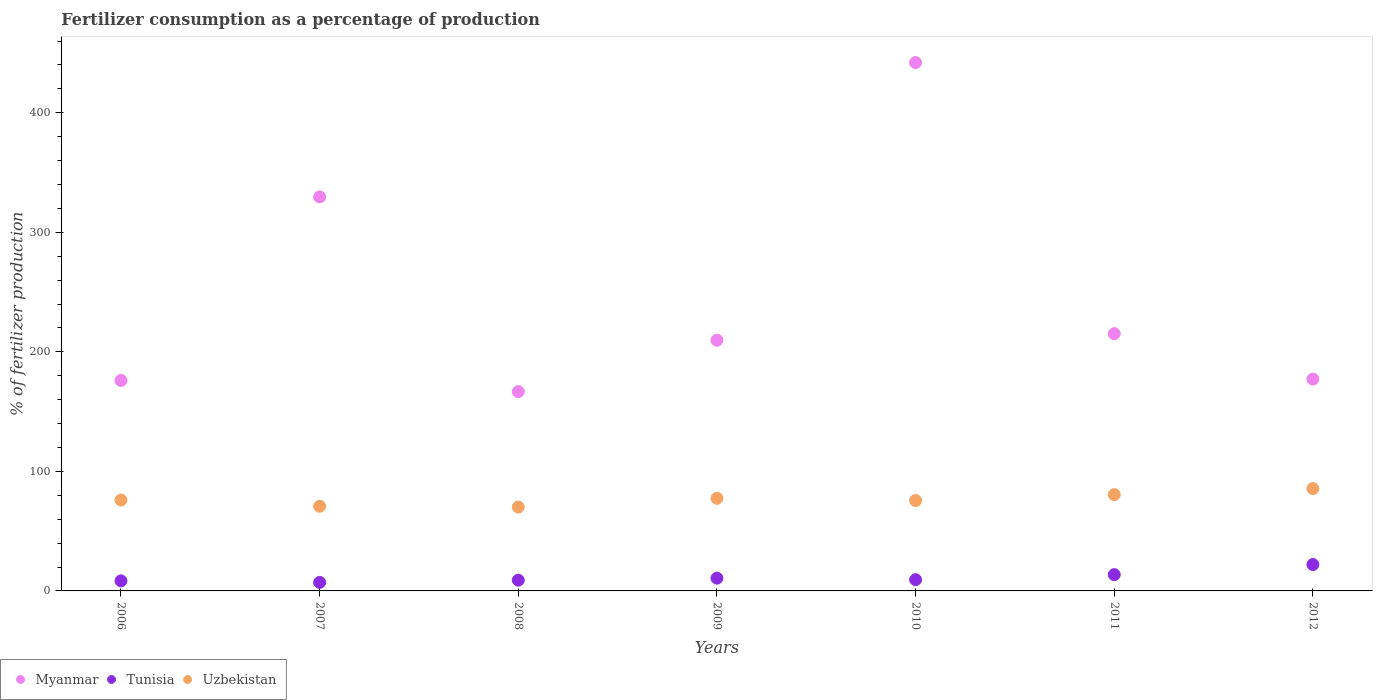What is the percentage of fertilizers consumed in Myanmar in 2007?
Keep it short and to the point. 329.61. Across all years, what is the maximum percentage of fertilizers consumed in Tunisia?
Provide a succinct answer. 22.07. Across all years, what is the minimum percentage of fertilizers consumed in Tunisia?
Keep it short and to the point. 7.13. In which year was the percentage of fertilizers consumed in Uzbekistan minimum?
Make the answer very short. 2008. What is the total percentage of fertilizers consumed in Myanmar in the graph?
Provide a succinct answer. 1716.48. What is the difference between the percentage of fertilizers consumed in Myanmar in 2006 and that in 2011?
Provide a short and direct response. -39.09. What is the difference between the percentage of fertilizers consumed in Myanmar in 2011 and the percentage of fertilizers consumed in Tunisia in 2010?
Your answer should be very brief. 205.79. What is the average percentage of fertilizers consumed in Uzbekistan per year?
Give a very brief answer. 76.61. In the year 2008, what is the difference between the percentage of fertilizers consumed in Myanmar and percentage of fertilizers consumed in Uzbekistan?
Provide a succinct answer. 96.5. In how many years, is the percentage of fertilizers consumed in Tunisia greater than 440 %?
Offer a terse response. 0. What is the ratio of the percentage of fertilizers consumed in Uzbekistan in 2006 to that in 2012?
Make the answer very short. 0.89. Is the percentage of fertilizers consumed in Tunisia in 2006 less than that in 2009?
Make the answer very short. Yes. Is the difference between the percentage of fertilizers consumed in Myanmar in 2007 and 2012 greater than the difference between the percentage of fertilizers consumed in Uzbekistan in 2007 and 2012?
Make the answer very short. Yes. What is the difference between the highest and the second highest percentage of fertilizers consumed in Uzbekistan?
Provide a short and direct response. 5.05. What is the difference between the highest and the lowest percentage of fertilizers consumed in Myanmar?
Offer a terse response. 275.3. Is the sum of the percentage of fertilizers consumed in Myanmar in 2009 and 2012 greater than the maximum percentage of fertilizers consumed in Tunisia across all years?
Your answer should be very brief. Yes. Is the percentage of fertilizers consumed in Tunisia strictly less than the percentage of fertilizers consumed in Myanmar over the years?
Your answer should be compact. Yes. How many years are there in the graph?
Your answer should be compact. 7. Are the values on the major ticks of Y-axis written in scientific E-notation?
Make the answer very short. No. Where does the legend appear in the graph?
Your response must be concise. Bottom left. How are the legend labels stacked?
Provide a succinct answer. Horizontal. What is the title of the graph?
Make the answer very short. Fertilizer consumption as a percentage of production. Does "Chad" appear as one of the legend labels in the graph?
Ensure brevity in your answer.  No. What is the label or title of the Y-axis?
Keep it short and to the point. % of fertilizer production. What is the % of fertilizer production in Myanmar in 2006?
Ensure brevity in your answer.  176.08. What is the % of fertilizer production in Tunisia in 2006?
Your answer should be compact. 8.41. What is the % of fertilizer production in Uzbekistan in 2006?
Ensure brevity in your answer.  76.02. What is the % of fertilizer production of Myanmar in 2007?
Make the answer very short. 329.61. What is the % of fertilizer production in Tunisia in 2007?
Give a very brief answer. 7.13. What is the % of fertilizer production in Uzbekistan in 2007?
Your answer should be very brief. 70.8. What is the % of fertilizer production of Myanmar in 2008?
Your answer should be very brief. 166.68. What is the % of fertilizer production of Tunisia in 2008?
Your answer should be very brief. 8.99. What is the % of fertilizer production of Uzbekistan in 2008?
Your answer should be compact. 70.18. What is the % of fertilizer production in Myanmar in 2009?
Ensure brevity in your answer.  209.73. What is the % of fertilizer production of Tunisia in 2009?
Ensure brevity in your answer.  10.66. What is the % of fertilizer production of Uzbekistan in 2009?
Make the answer very short. 77.46. What is the % of fertilizer production in Myanmar in 2010?
Provide a short and direct response. 441.98. What is the % of fertilizer production in Tunisia in 2010?
Your answer should be very brief. 9.38. What is the % of fertilizer production of Uzbekistan in 2010?
Give a very brief answer. 75.64. What is the % of fertilizer production in Myanmar in 2011?
Your answer should be compact. 215.18. What is the % of fertilizer production of Tunisia in 2011?
Offer a terse response. 13.63. What is the % of fertilizer production in Uzbekistan in 2011?
Your answer should be very brief. 80.55. What is the % of fertilizer production of Myanmar in 2012?
Offer a very short reply. 177.22. What is the % of fertilizer production of Tunisia in 2012?
Provide a short and direct response. 22.07. What is the % of fertilizer production in Uzbekistan in 2012?
Offer a very short reply. 85.6. Across all years, what is the maximum % of fertilizer production in Myanmar?
Make the answer very short. 441.98. Across all years, what is the maximum % of fertilizer production of Tunisia?
Ensure brevity in your answer.  22.07. Across all years, what is the maximum % of fertilizer production in Uzbekistan?
Keep it short and to the point. 85.6. Across all years, what is the minimum % of fertilizer production of Myanmar?
Your answer should be very brief. 166.68. Across all years, what is the minimum % of fertilizer production of Tunisia?
Your answer should be compact. 7.13. Across all years, what is the minimum % of fertilizer production in Uzbekistan?
Your answer should be compact. 70.18. What is the total % of fertilizer production in Myanmar in the graph?
Ensure brevity in your answer.  1716.48. What is the total % of fertilizer production of Tunisia in the graph?
Make the answer very short. 80.27. What is the total % of fertilizer production of Uzbekistan in the graph?
Ensure brevity in your answer.  536.26. What is the difference between the % of fertilizer production of Myanmar in 2006 and that in 2007?
Make the answer very short. -153.53. What is the difference between the % of fertilizer production of Tunisia in 2006 and that in 2007?
Your response must be concise. 1.28. What is the difference between the % of fertilizer production in Uzbekistan in 2006 and that in 2007?
Offer a terse response. 5.21. What is the difference between the % of fertilizer production in Myanmar in 2006 and that in 2008?
Your response must be concise. 9.4. What is the difference between the % of fertilizer production of Tunisia in 2006 and that in 2008?
Offer a terse response. -0.57. What is the difference between the % of fertilizer production in Uzbekistan in 2006 and that in 2008?
Keep it short and to the point. 5.83. What is the difference between the % of fertilizer production in Myanmar in 2006 and that in 2009?
Give a very brief answer. -33.64. What is the difference between the % of fertilizer production of Tunisia in 2006 and that in 2009?
Your answer should be compact. -2.24. What is the difference between the % of fertilizer production of Uzbekistan in 2006 and that in 2009?
Provide a succinct answer. -1.45. What is the difference between the % of fertilizer production of Myanmar in 2006 and that in 2010?
Keep it short and to the point. -265.89. What is the difference between the % of fertilizer production of Tunisia in 2006 and that in 2010?
Your response must be concise. -0.97. What is the difference between the % of fertilizer production of Uzbekistan in 2006 and that in 2010?
Make the answer very short. 0.37. What is the difference between the % of fertilizer production of Myanmar in 2006 and that in 2011?
Offer a terse response. -39.09. What is the difference between the % of fertilizer production of Tunisia in 2006 and that in 2011?
Ensure brevity in your answer.  -5.22. What is the difference between the % of fertilizer production in Uzbekistan in 2006 and that in 2011?
Provide a succinct answer. -4.54. What is the difference between the % of fertilizer production of Myanmar in 2006 and that in 2012?
Your answer should be compact. -1.14. What is the difference between the % of fertilizer production of Tunisia in 2006 and that in 2012?
Offer a very short reply. -13.66. What is the difference between the % of fertilizer production in Uzbekistan in 2006 and that in 2012?
Provide a succinct answer. -9.59. What is the difference between the % of fertilizer production in Myanmar in 2007 and that in 2008?
Offer a very short reply. 162.93. What is the difference between the % of fertilizer production in Tunisia in 2007 and that in 2008?
Offer a terse response. -1.86. What is the difference between the % of fertilizer production of Uzbekistan in 2007 and that in 2008?
Provide a short and direct response. 0.62. What is the difference between the % of fertilizer production of Myanmar in 2007 and that in 2009?
Give a very brief answer. 119.89. What is the difference between the % of fertilizer production in Tunisia in 2007 and that in 2009?
Provide a short and direct response. -3.53. What is the difference between the % of fertilizer production of Uzbekistan in 2007 and that in 2009?
Provide a short and direct response. -6.66. What is the difference between the % of fertilizer production of Myanmar in 2007 and that in 2010?
Your answer should be compact. -112.36. What is the difference between the % of fertilizer production of Tunisia in 2007 and that in 2010?
Provide a succinct answer. -2.25. What is the difference between the % of fertilizer production of Uzbekistan in 2007 and that in 2010?
Make the answer very short. -4.84. What is the difference between the % of fertilizer production of Myanmar in 2007 and that in 2011?
Give a very brief answer. 114.44. What is the difference between the % of fertilizer production in Tunisia in 2007 and that in 2011?
Your response must be concise. -6.5. What is the difference between the % of fertilizer production of Uzbekistan in 2007 and that in 2011?
Provide a succinct answer. -9.75. What is the difference between the % of fertilizer production in Myanmar in 2007 and that in 2012?
Provide a short and direct response. 152.39. What is the difference between the % of fertilizer production of Tunisia in 2007 and that in 2012?
Offer a terse response. -14.94. What is the difference between the % of fertilizer production in Uzbekistan in 2007 and that in 2012?
Your response must be concise. -14.8. What is the difference between the % of fertilizer production in Myanmar in 2008 and that in 2009?
Provide a short and direct response. -43.05. What is the difference between the % of fertilizer production in Tunisia in 2008 and that in 2009?
Offer a very short reply. -1.67. What is the difference between the % of fertilizer production in Uzbekistan in 2008 and that in 2009?
Give a very brief answer. -7.28. What is the difference between the % of fertilizer production in Myanmar in 2008 and that in 2010?
Your response must be concise. -275.3. What is the difference between the % of fertilizer production in Tunisia in 2008 and that in 2010?
Make the answer very short. -0.4. What is the difference between the % of fertilizer production of Uzbekistan in 2008 and that in 2010?
Your answer should be compact. -5.46. What is the difference between the % of fertilizer production in Myanmar in 2008 and that in 2011?
Your response must be concise. -48.5. What is the difference between the % of fertilizer production of Tunisia in 2008 and that in 2011?
Give a very brief answer. -4.65. What is the difference between the % of fertilizer production in Uzbekistan in 2008 and that in 2011?
Keep it short and to the point. -10.37. What is the difference between the % of fertilizer production in Myanmar in 2008 and that in 2012?
Your answer should be very brief. -10.54. What is the difference between the % of fertilizer production in Tunisia in 2008 and that in 2012?
Offer a terse response. -13.08. What is the difference between the % of fertilizer production of Uzbekistan in 2008 and that in 2012?
Offer a very short reply. -15.42. What is the difference between the % of fertilizer production in Myanmar in 2009 and that in 2010?
Your response must be concise. -232.25. What is the difference between the % of fertilizer production in Tunisia in 2009 and that in 2010?
Provide a short and direct response. 1.27. What is the difference between the % of fertilizer production in Uzbekistan in 2009 and that in 2010?
Give a very brief answer. 1.82. What is the difference between the % of fertilizer production in Myanmar in 2009 and that in 2011?
Your answer should be compact. -5.45. What is the difference between the % of fertilizer production of Tunisia in 2009 and that in 2011?
Offer a terse response. -2.97. What is the difference between the % of fertilizer production in Uzbekistan in 2009 and that in 2011?
Offer a very short reply. -3.09. What is the difference between the % of fertilizer production of Myanmar in 2009 and that in 2012?
Give a very brief answer. 32.51. What is the difference between the % of fertilizer production of Tunisia in 2009 and that in 2012?
Provide a short and direct response. -11.41. What is the difference between the % of fertilizer production of Uzbekistan in 2009 and that in 2012?
Make the answer very short. -8.14. What is the difference between the % of fertilizer production of Myanmar in 2010 and that in 2011?
Ensure brevity in your answer.  226.8. What is the difference between the % of fertilizer production of Tunisia in 2010 and that in 2011?
Keep it short and to the point. -4.25. What is the difference between the % of fertilizer production of Uzbekistan in 2010 and that in 2011?
Your answer should be very brief. -4.91. What is the difference between the % of fertilizer production of Myanmar in 2010 and that in 2012?
Provide a succinct answer. 264.76. What is the difference between the % of fertilizer production of Tunisia in 2010 and that in 2012?
Keep it short and to the point. -12.69. What is the difference between the % of fertilizer production of Uzbekistan in 2010 and that in 2012?
Keep it short and to the point. -9.96. What is the difference between the % of fertilizer production in Myanmar in 2011 and that in 2012?
Your answer should be compact. 37.96. What is the difference between the % of fertilizer production in Tunisia in 2011 and that in 2012?
Ensure brevity in your answer.  -8.44. What is the difference between the % of fertilizer production in Uzbekistan in 2011 and that in 2012?
Make the answer very short. -5.05. What is the difference between the % of fertilizer production of Myanmar in 2006 and the % of fertilizer production of Tunisia in 2007?
Your answer should be very brief. 168.95. What is the difference between the % of fertilizer production in Myanmar in 2006 and the % of fertilizer production in Uzbekistan in 2007?
Give a very brief answer. 105.28. What is the difference between the % of fertilizer production in Tunisia in 2006 and the % of fertilizer production in Uzbekistan in 2007?
Your answer should be very brief. -62.39. What is the difference between the % of fertilizer production in Myanmar in 2006 and the % of fertilizer production in Tunisia in 2008?
Your answer should be compact. 167.1. What is the difference between the % of fertilizer production in Myanmar in 2006 and the % of fertilizer production in Uzbekistan in 2008?
Provide a short and direct response. 105.9. What is the difference between the % of fertilizer production in Tunisia in 2006 and the % of fertilizer production in Uzbekistan in 2008?
Your response must be concise. -61.77. What is the difference between the % of fertilizer production of Myanmar in 2006 and the % of fertilizer production of Tunisia in 2009?
Ensure brevity in your answer.  165.43. What is the difference between the % of fertilizer production of Myanmar in 2006 and the % of fertilizer production of Uzbekistan in 2009?
Provide a succinct answer. 98.62. What is the difference between the % of fertilizer production of Tunisia in 2006 and the % of fertilizer production of Uzbekistan in 2009?
Provide a succinct answer. -69.05. What is the difference between the % of fertilizer production in Myanmar in 2006 and the % of fertilizer production in Tunisia in 2010?
Your answer should be compact. 166.7. What is the difference between the % of fertilizer production of Myanmar in 2006 and the % of fertilizer production of Uzbekistan in 2010?
Your answer should be compact. 100.44. What is the difference between the % of fertilizer production of Tunisia in 2006 and the % of fertilizer production of Uzbekistan in 2010?
Ensure brevity in your answer.  -67.23. What is the difference between the % of fertilizer production in Myanmar in 2006 and the % of fertilizer production in Tunisia in 2011?
Provide a short and direct response. 162.45. What is the difference between the % of fertilizer production in Myanmar in 2006 and the % of fertilizer production in Uzbekistan in 2011?
Ensure brevity in your answer.  95.53. What is the difference between the % of fertilizer production of Tunisia in 2006 and the % of fertilizer production of Uzbekistan in 2011?
Provide a succinct answer. -72.14. What is the difference between the % of fertilizer production of Myanmar in 2006 and the % of fertilizer production of Tunisia in 2012?
Give a very brief answer. 154.01. What is the difference between the % of fertilizer production in Myanmar in 2006 and the % of fertilizer production in Uzbekistan in 2012?
Your answer should be very brief. 90.48. What is the difference between the % of fertilizer production in Tunisia in 2006 and the % of fertilizer production in Uzbekistan in 2012?
Provide a succinct answer. -77.19. What is the difference between the % of fertilizer production of Myanmar in 2007 and the % of fertilizer production of Tunisia in 2008?
Give a very brief answer. 320.63. What is the difference between the % of fertilizer production in Myanmar in 2007 and the % of fertilizer production in Uzbekistan in 2008?
Offer a terse response. 259.43. What is the difference between the % of fertilizer production of Tunisia in 2007 and the % of fertilizer production of Uzbekistan in 2008?
Give a very brief answer. -63.05. What is the difference between the % of fertilizer production of Myanmar in 2007 and the % of fertilizer production of Tunisia in 2009?
Ensure brevity in your answer.  318.96. What is the difference between the % of fertilizer production in Myanmar in 2007 and the % of fertilizer production in Uzbekistan in 2009?
Your answer should be compact. 252.15. What is the difference between the % of fertilizer production of Tunisia in 2007 and the % of fertilizer production of Uzbekistan in 2009?
Your answer should be very brief. -70.33. What is the difference between the % of fertilizer production of Myanmar in 2007 and the % of fertilizer production of Tunisia in 2010?
Your response must be concise. 320.23. What is the difference between the % of fertilizer production of Myanmar in 2007 and the % of fertilizer production of Uzbekistan in 2010?
Make the answer very short. 253.97. What is the difference between the % of fertilizer production of Tunisia in 2007 and the % of fertilizer production of Uzbekistan in 2010?
Provide a short and direct response. -68.51. What is the difference between the % of fertilizer production in Myanmar in 2007 and the % of fertilizer production in Tunisia in 2011?
Offer a very short reply. 315.98. What is the difference between the % of fertilizer production of Myanmar in 2007 and the % of fertilizer production of Uzbekistan in 2011?
Give a very brief answer. 249.06. What is the difference between the % of fertilizer production of Tunisia in 2007 and the % of fertilizer production of Uzbekistan in 2011?
Your answer should be compact. -73.42. What is the difference between the % of fertilizer production in Myanmar in 2007 and the % of fertilizer production in Tunisia in 2012?
Make the answer very short. 307.54. What is the difference between the % of fertilizer production in Myanmar in 2007 and the % of fertilizer production in Uzbekistan in 2012?
Offer a very short reply. 244.01. What is the difference between the % of fertilizer production in Tunisia in 2007 and the % of fertilizer production in Uzbekistan in 2012?
Keep it short and to the point. -78.47. What is the difference between the % of fertilizer production in Myanmar in 2008 and the % of fertilizer production in Tunisia in 2009?
Your answer should be very brief. 156.02. What is the difference between the % of fertilizer production in Myanmar in 2008 and the % of fertilizer production in Uzbekistan in 2009?
Ensure brevity in your answer.  89.22. What is the difference between the % of fertilizer production of Tunisia in 2008 and the % of fertilizer production of Uzbekistan in 2009?
Your response must be concise. -68.48. What is the difference between the % of fertilizer production in Myanmar in 2008 and the % of fertilizer production in Tunisia in 2010?
Your response must be concise. 157.3. What is the difference between the % of fertilizer production of Myanmar in 2008 and the % of fertilizer production of Uzbekistan in 2010?
Your answer should be compact. 91.04. What is the difference between the % of fertilizer production of Tunisia in 2008 and the % of fertilizer production of Uzbekistan in 2010?
Your response must be concise. -66.66. What is the difference between the % of fertilizer production of Myanmar in 2008 and the % of fertilizer production of Tunisia in 2011?
Offer a very short reply. 153.05. What is the difference between the % of fertilizer production in Myanmar in 2008 and the % of fertilizer production in Uzbekistan in 2011?
Offer a very short reply. 86.13. What is the difference between the % of fertilizer production in Tunisia in 2008 and the % of fertilizer production in Uzbekistan in 2011?
Your answer should be compact. -71.57. What is the difference between the % of fertilizer production of Myanmar in 2008 and the % of fertilizer production of Tunisia in 2012?
Give a very brief answer. 144.61. What is the difference between the % of fertilizer production in Myanmar in 2008 and the % of fertilizer production in Uzbekistan in 2012?
Offer a very short reply. 81.08. What is the difference between the % of fertilizer production in Tunisia in 2008 and the % of fertilizer production in Uzbekistan in 2012?
Your answer should be very brief. -76.62. What is the difference between the % of fertilizer production in Myanmar in 2009 and the % of fertilizer production in Tunisia in 2010?
Offer a very short reply. 200.34. What is the difference between the % of fertilizer production in Myanmar in 2009 and the % of fertilizer production in Uzbekistan in 2010?
Your response must be concise. 134.09. What is the difference between the % of fertilizer production of Tunisia in 2009 and the % of fertilizer production of Uzbekistan in 2010?
Ensure brevity in your answer.  -64.99. What is the difference between the % of fertilizer production in Myanmar in 2009 and the % of fertilizer production in Tunisia in 2011?
Offer a very short reply. 196.1. What is the difference between the % of fertilizer production in Myanmar in 2009 and the % of fertilizer production in Uzbekistan in 2011?
Offer a very short reply. 129.18. What is the difference between the % of fertilizer production of Tunisia in 2009 and the % of fertilizer production of Uzbekistan in 2011?
Give a very brief answer. -69.9. What is the difference between the % of fertilizer production in Myanmar in 2009 and the % of fertilizer production in Tunisia in 2012?
Your response must be concise. 187.66. What is the difference between the % of fertilizer production in Myanmar in 2009 and the % of fertilizer production in Uzbekistan in 2012?
Keep it short and to the point. 124.12. What is the difference between the % of fertilizer production in Tunisia in 2009 and the % of fertilizer production in Uzbekistan in 2012?
Give a very brief answer. -74.95. What is the difference between the % of fertilizer production of Myanmar in 2010 and the % of fertilizer production of Tunisia in 2011?
Your response must be concise. 428.35. What is the difference between the % of fertilizer production in Myanmar in 2010 and the % of fertilizer production in Uzbekistan in 2011?
Offer a very short reply. 361.43. What is the difference between the % of fertilizer production in Tunisia in 2010 and the % of fertilizer production in Uzbekistan in 2011?
Provide a short and direct response. -71.17. What is the difference between the % of fertilizer production of Myanmar in 2010 and the % of fertilizer production of Tunisia in 2012?
Your answer should be very brief. 419.91. What is the difference between the % of fertilizer production in Myanmar in 2010 and the % of fertilizer production in Uzbekistan in 2012?
Keep it short and to the point. 356.37. What is the difference between the % of fertilizer production of Tunisia in 2010 and the % of fertilizer production of Uzbekistan in 2012?
Provide a succinct answer. -76.22. What is the difference between the % of fertilizer production of Myanmar in 2011 and the % of fertilizer production of Tunisia in 2012?
Keep it short and to the point. 193.11. What is the difference between the % of fertilizer production in Myanmar in 2011 and the % of fertilizer production in Uzbekistan in 2012?
Keep it short and to the point. 129.57. What is the difference between the % of fertilizer production of Tunisia in 2011 and the % of fertilizer production of Uzbekistan in 2012?
Give a very brief answer. -71.97. What is the average % of fertilizer production in Myanmar per year?
Keep it short and to the point. 245.21. What is the average % of fertilizer production in Tunisia per year?
Provide a short and direct response. 11.47. What is the average % of fertilizer production in Uzbekistan per year?
Your answer should be compact. 76.61. In the year 2006, what is the difference between the % of fertilizer production in Myanmar and % of fertilizer production in Tunisia?
Provide a succinct answer. 167.67. In the year 2006, what is the difference between the % of fertilizer production in Myanmar and % of fertilizer production in Uzbekistan?
Ensure brevity in your answer.  100.07. In the year 2006, what is the difference between the % of fertilizer production in Tunisia and % of fertilizer production in Uzbekistan?
Keep it short and to the point. -67.6. In the year 2007, what is the difference between the % of fertilizer production in Myanmar and % of fertilizer production in Tunisia?
Keep it short and to the point. 322.48. In the year 2007, what is the difference between the % of fertilizer production in Myanmar and % of fertilizer production in Uzbekistan?
Give a very brief answer. 258.81. In the year 2007, what is the difference between the % of fertilizer production of Tunisia and % of fertilizer production of Uzbekistan?
Your answer should be compact. -63.67. In the year 2008, what is the difference between the % of fertilizer production in Myanmar and % of fertilizer production in Tunisia?
Offer a terse response. 157.69. In the year 2008, what is the difference between the % of fertilizer production in Myanmar and % of fertilizer production in Uzbekistan?
Provide a succinct answer. 96.5. In the year 2008, what is the difference between the % of fertilizer production in Tunisia and % of fertilizer production in Uzbekistan?
Make the answer very short. -61.2. In the year 2009, what is the difference between the % of fertilizer production in Myanmar and % of fertilizer production in Tunisia?
Your answer should be very brief. 199.07. In the year 2009, what is the difference between the % of fertilizer production in Myanmar and % of fertilizer production in Uzbekistan?
Your answer should be compact. 132.26. In the year 2009, what is the difference between the % of fertilizer production of Tunisia and % of fertilizer production of Uzbekistan?
Keep it short and to the point. -66.81. In the year 2010, what is the difference between the % of fertilizer production in Myanmar and % of fertilizer production in Tunisia?
Offer a terse response. 432.59. In the year 2010, what is the difference between the % of fertilizer production in Myanmar and % of fertilizer production in Uzbekistan?
Give a very brief answer. 366.34. In the year 2010, what is the difference between the % of fertilizer production in Tunisia and % of fertilizer production in Uzbekistan?
Give a very brief answer. -66.26. In the year 2011, what is the difference between the % of fertilizer production in Myanmar and % of fertilizer production in Tunisia?
Keep it short and to the point. 201.55. In the year 2011, what is the difference between the % of fertilizer production in Myanmar and % of fertilizer production in Uzbekistan?
Your response must be concise. 134.63. In the year 2011, what is the difference between the % of fertilizer production of Tunisia and % of fertilizer production of Uzbekistan?
Provide a short and direct response. -66.92. In the year 2012, what is the difference between the % of fertilizer production in Myanmar and % of fertilizer production in Tunisia?
Provide a succinct answer. 155.15. In the year 2012, what is the difference between the % of fertilizer production in Myanmar and % of fertilizer production in Uzbekistan?
Ensure brevity in your answer.  91.62. In the year 2012, what is the difference between the % of fertilizer production of Tunisia and % of fertilizer production of Uzbekistan?
Provide a short and direct response. -63.53. What is the ratio of the % of fertilizer production of Myanmar in 2006 to that in 2007?
Provide a succinct answer. 0.53. What is the ratio of the % of fertilizer production of Tunisia in 2006 to that in 2007?
Provide a short and direct response. 1.18. What is the ratio of the % of fertilizer production of Uzbekistan in 2006 to that in 2007?
Make the answer very short. 1.07. What is the ratio of the % of fertilizer production of Myanmar in 2006 to that in 2008?
Your answer should be compact. 1.06. What is the ratio of the % of fertilizer production of Tunisia in 2006 to that in 2008?
Offer a very short reply. 0.94. What is the ratio of the % of fertilizer production of Uzbekistan in 2006 to that in 2008?
Your answer should be compact. 1.08. What is the ratio of the % of fertilizer production of Myanmar in 2006 to that in 2009?
Ensure brevity in your answer.  0.84. What is the ratio of the % of fertilizer production in Tunisia in 2006 to that in 2009?
Keep it short and to the point. 0.79. What is the ratio of the % of fertilizer production of Uzbekistan in 2006 to that in 2009?
Provide a short and direct response. 0.98. What is the ratio of the % of fertilizer production in Myanmar in 2006 to that in 2010?
Provide a succinct answer. 0.4. What is the ratio of the % of fertilizer production of Tunisia in 2006 to that in 2010?
Offer a very short reply. 0.9. What is the ratio of the % of fertilizer production of Uzbekistan in 2006 to that in 2010?
Offer a very short reply. 1. What is the ratio of the % of fertilizer production of Myanmar in 2006 to that in 2011?
Make the answer very short. 0.82. What is the ratio of the % of fertilizer production of Tunisia in 2006 to that in 2011?
Offer a terse response. 0.62. What is the ratio of the % of fertilizer production of Uzbekistan in 2006 to that in 2011?
Provide a short and direct response. 0.94. What is the ratio of the % of fertilizer production of Myanmar in 2006 to that in 2012?
Offer a terse response. 0.99. What is the ratio of the % of fertilizer production in Tunisia in 2006 to that in 2012?
Offer a very short reply. 0.38. What is the ratio of the % of fertilizer production in Uzbekistan in 2006 to that in 2012?
Give a very brief answer. 0.89. What is the ratio of the % of fertilizer production of Myanmar in 2007 to that in 2008?
Your response must be concise. 1.98. What is the ratio of the % of fertilizer production in Tunisia in 2007 to that in 2008?
Make the answer very short. 0.79. What is the ratio of the % of fertilizer production of Uzbekistan in 2007 to that in 2008?
Give a very brief answer. 1.01. What is the ratio of the % of fertilizer production in Myanmar in 2007 to that in 2009?
Ensure brevity in your answer.  1.57. What is the ratio of the % of fertilizer production in Tunisia in 2007 to that in 2009?
Give a very brief answer. 0.67. What is the ratio of the % of fertilizer production of Uzbekistan in 2007 to that in 2009?
Your answer should be compact. 0.91. What is the ratio of the % of fertilizer production of Myanmar in 2007 to that in 2010?
Provide a succinct answer. 0.75. What is the ratio of the % of fertilizer production of Tunisia in 2007 to that in 2010?
Offer a terse response. 0.76. What is the ratio of the % of fertilizer production in Uzbekistan in 2007 to that in 2010?
Provide a succinct answer. 0.94. What is the ratio of the % of fertilizer production of Myanmar in 2007 to that in 2011?
Give a very brief answer. 1.53. What is the ratio of the % of fertilizer production of Tunisia in 2007 to that in 2011?
Your answer should be compact. 0.52. What is the ratio of the % of fertilizer production in Uzbekistan in 2007 to that in 2011?
Offer a very short reply. 0.88. What is the ratio of the % of fertilizer production in Myanmar in 2007 to that in 2012?
Provide a short and direct response. 1.86. What is the ratio of the % of fertilizer production in Tunisia in 2007 to that in 2012?
Your answer should be very brief. 0.32. What is the ratio of the % of fertilizer production of Uzbekistan in 2007 to that in 2012?
Your answer should be compact. 0.83. What is the ratio of the % of fertilizer production of Myanmar in 2008 to that in 2009?
Ensure brevity in your answer.  0.79. What is the ratio of the % of fertilizer production of Tunisia in 2008 to that in 2009?
Provide a short and direct response. 0.84. What is the ratio of the % of fertilizer production of Uzbekistan in 2008 to that in 2009?
Your answer should be very brief. 0.91. What is the ratio of the % of fertilizer production of Myanmar in 2008 to that in 2010?
Make the answer very short. 0.38. What is the ratio of the % of fertilizer production in Tunisia in 2008 to that in 2010?
Keep it short and to the point. 0.96. What is the ratio of the % of fertilizer production in Uzbekistan in 2008 to that in 2010?
Your answer should be very brief. 0.93. What is the ratio of the % of fertilizer production of Myanmar in 2008 to that in 2011?
Ensure brevity in your answer.  0.77. What is the ratio of the % of fertilizer production in Tunisia in 2008 to that in 2011?
Provide a succinct answer. 0.66. What is the ratio of the % of fertilizer production in Uzbekistan in 2008 to that in 2011?
Provide a succinct answer. 0.87. What is the ratio of the % of fertilizer production of Myanmar in 2008 to that in 2012?
Ensure brevity in your answer.  0.94. What is the ratio of the % of fertilizer production of Tunisia in 2008 to that in 2012?
Keep it short and to the point. 0.41. What is the ratio of the % of fertilizer production in Uzbekistan in 2008 to that in 2012?
Your answer should be very brief. 0.82. What is the ratio of the % of fertilizer production in Myanmar in 2009 to that in 2010?
Keep it short and to the point. 0.47. What is the ratio of the % of fertilizer production of Tunisia in 2009 to that in 2010?
Give a very brief answer. 1.14. What is the ratio of the % of fertilizer production in Uzbekistan in 2009 to that in 2010?
Your answer should be compact. 1.02. What is the ratio of the % of fertilizer production of Myanmar in 2009 to that in 2011?
Your response must be concise. 0.97. What is the ratio of the % of fertilizer production in Tunisia in 2009 to that in 2011?
Offer a terse response. 0.78. What is the ratio of the % of fertilizer production of Uzbekistan in 2009 to that in 2011?
Offer a terse response. 0.96. What is the ratio of the % of fertilizer production of Myanmar in 2009 to that in 2012?
Your response must be concise. 1.18. What is the ratio of the % of fertilizer production in Tunisia in 2009 to that in 2012?
Your response must be concise. 0.48. What is the ratio of the % of fertilizer production of Uzbekistan in 2009 to that in 2012?
Your answer should be very brief. 0.9. What is the ratio of the % of fertilizer production of Myanmar in 2010 to that in 2011?
Offer a very short reply. 2.05. What is the ratio of the % of fertilizer production in Tunisia in 2010 to that in 2011?
Make the answer very short. 0.69. What is the ratio of the % of fertilizer production of Uzbekistan in 2010 to that in 2011?
Provide a succinct answer. 0.94. What is the ratio of the % of fertilizer production of Myanmar in 2010 to that in 2012?
Offer a terse response. 2.49. What is the ratio of the % of fertilizer production of Tunisia in 2010 to that in 2012?
Your answer should be very brief. 0.43. What is the ratio of the % of fertilizer production in Uzbekistan in 2010 to that in 2012?
Give a very brief answer. 0.88. What is the ratio of the % of fertilizer production of Myanmar in 2011 to that in 2012?
Provide a succinct answer. 1.21. What is the ratio of the % of fertilizer production in Tunisia in 2011 to that in 2012?
Keep it short and to the point. 0.62. What is the ratio of the % of fertilizer production of Uzbekistan in 2011 to that in 2012?
Provide a succinct answer. 0.94. What is the difference between the highest and the second highest % of fertilizer production of Myanmar?
Ensure brevity in your answer.  112.36. What is the difference between the highest and the second highest % of fertilizer production in Tunisia?
Give a very brief answer. 8.44. What is the difference between the highest and the second highest % of fertilizer production of Uzbekistan?
Ensure brevity in your answer.  5.05. What is the difference between the highest and the lowest % of fertilizer production in Myanmar?
Provide a succinct answer. 275.3. What is the difference between the highest and the lowest % of fertilizer production in Tunisia?
Offer a very short reply. 14.94. What is the difference between the highest and the lowest % of fertilizer production of Uzbekistan?
Provide a succinct answer. 15.42. 